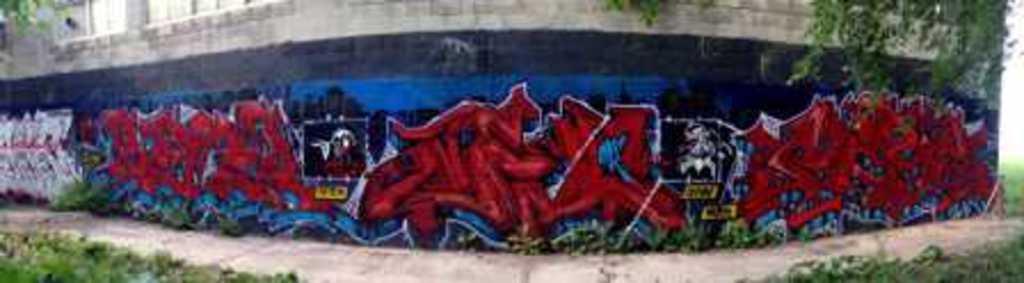Can you describe this image briefly? In the center of the image there is a wall with graffiti on it. 